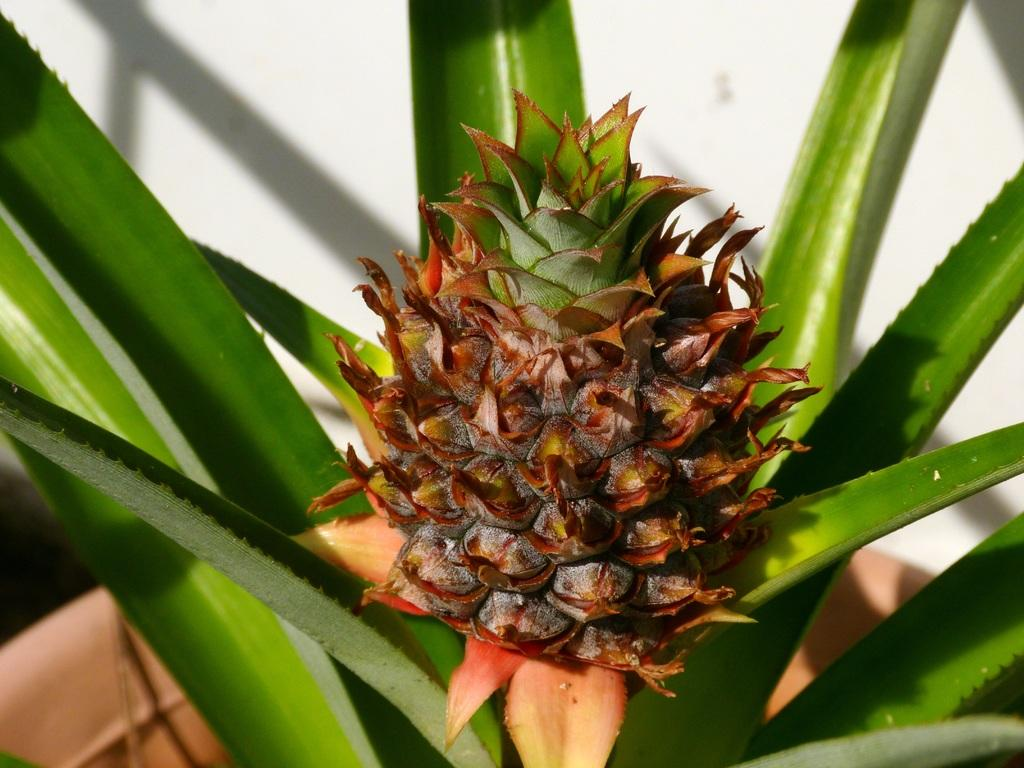What type of living organism can be seen in the image? There is a plant in the image. What type of food is visible in the image? There is a fruit in the image. What type of structure is present in the image? There is a wall in the image. How many ants are crawling on the fruit in the image? There are no ants present in the image; only the plant, fruit, and wall can be seen. 